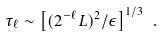<formula> <loc_0><loc_0><loc_500><loc_500>\tau _ { \ell } \sim \left [ ( 2 ^ { - \ell } L ) ^ { 2 } / \epsilon \right ] ^ { 1 / 3 } \ .</formula> 